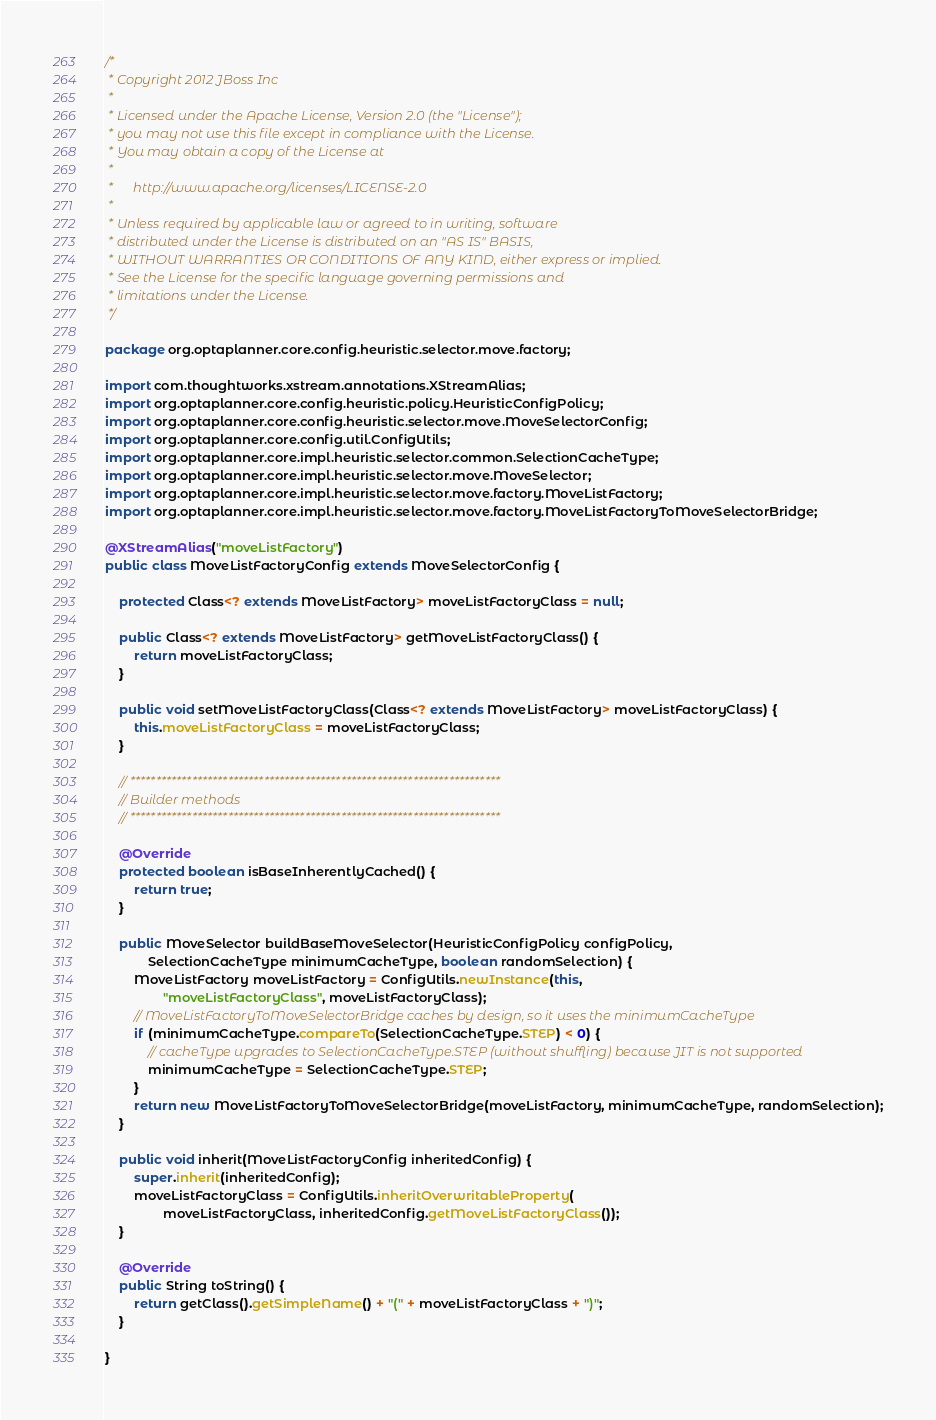Convert code to text. <code><loc_0><loc_0><loc_500><loc_500><_Java_>/*
 * Copyright 2012 JBoss Inc
 *
 * Licensed under the Apache License, Version 2.0 (the "License");
 * you may not use this file except in compliance with the License.
 * You may obtain a copy of the License at
 *
 *      http://www.apache.org/licenses/LICENSE-2.0
 *
 * Unless required by applicable law or agreed to in writing, software
 * distributed under the License is distributed on an "AS IS" BASIS,
 * WITHOUT WARRANTIES OR CONDITIONS OF ANY KIND, either express or implied.
 * See the License for the specific language governing permissions and
 * limitations under the License.
 */

package org.optaplanner.core.config.heuristic.selector.move.factory;

import com.thoughtworks.xstream.annotations.XStreamAlias;
import org.optaplanner.core.config.heuristic.policy.HeuristicConfigPolicy;
import org.optaplanner.core.config.heuristic.selector.move.MoveSelectorConfig;
import org.optaplanner.core.config.util.ConfigUtils;
import org.optaplanner.core.impl.heuristic.selector.common.SelectionCacheType;
import org.optaplanner.core.impl.heuristic.selector.move.MoveSelector;
import org.optaplanner.core.impl.heuristic.selector.move.factory.MoveListFactory;
import org.optaplanner.core.impl.heuristic.selector.move.factory.MoveListFactoryToMoveSelectorBridge;

@XStreamAlias("moveListFactory")
public class MoveListFactoryConfig extends MoveSelectorConfig {

    protected Class<? extends MoveListFactory> moveListFactoryClass = null;

    public Class<? extends MoveListFactory> getMoveListFactoryClass() {
        return moveListFactoryClass;
    }

    public void setMoveListFactoryClass(Class<? extends MoveListFactory> moveListFactoryClass) {
        this.moveListFactoryClass = moveListFactoryClass;
    }

    // ************************************************************************
    // Builder methods
    // ************************************************************************

    @Override
    protected boolean isBaseInherentlyCached() {
        return true;
    }

    public MoveSelector buildBaseMoveSelector(HeuristicConfigPolicy configPolicy,
            SelectionCacheType minimumCacheType, boolean randomSelection) {
        MoveListFactory moveListFactory = ConfigUtils.newInstance(this,
                "moveListFactoryClass", moveListFactoryClass);
        // MoveListFactoryToMoveSelectorBridge caches by design, so it uses the minimumCacheType
        if (minimumCacheType.compareTo(SelectionCacheType.STEP) < 0) {
            // cacheType upgrades to SelectionCacheType.STEP (without shuffling) because JIT is not supported
            minimumCacheType = SelectionCacheType.STEP;
        }
        return new MoveListFactoryToMoveSelectorBridge(moveListFactory, minimumCacheType, randomSelection);
    }

    public void inherit(MoveListFactoryConfig inheritedConfig) {
        super.inherit(inheritedConfig);
        moveListFactoryClass = ConfigUtils.inheritOverwritableProperty(
                moveListFactoryClass, inheritedConfig.getMoveListFactoryClass());
    }

    @Override
    public String toString() {
        return getClass().getSimpleName() + "(" + moveListFactoryClass + ")";
    }

}
</code> 